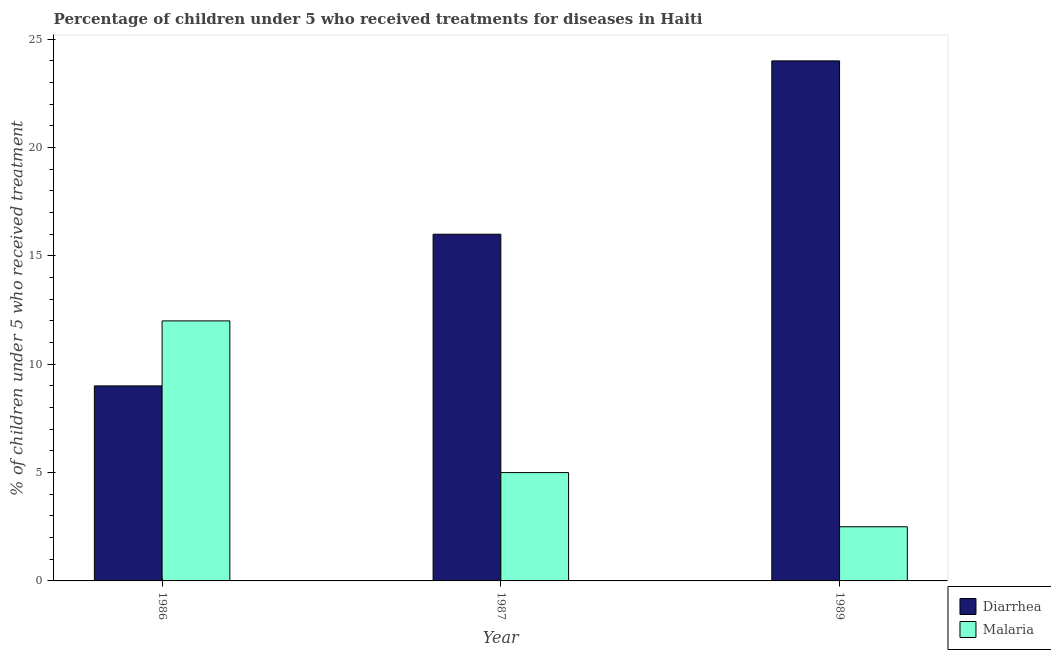Are the number of bars per tick equal to the number of legend labels?
Your answer should be very brief. Yes. Are the number of bars on each tick of the X-axis equal?
Keep it short and to the point. Yes. What is the label of the 1st group of bars from the left?
Offer a terse response. 1986. What is the percentage of children who received treatment for diarrhoea in 1986?
Ensure brevity in your answer.  9. Across all years, what is the maximum percentage of children who received treatment for malaria?
Offer a terse response. 12. Across all years, what is the minimum percentage of children who received treatment for malaria?
Give a very brief answer. 2.5. In which year was the percentage of children who received treatment for diarrhoea maximum?
Give a very brief answer. 1989. In which year was the percentage of children who received treatment for malaria minimum?
Provide a succinct answer. 1989. What is the total percentage of children who received treatment for diarrhoea in the graph?
Your response must be concise. 49. What is the difference between the percentage of children who received treatment for malaria in 1986 and that in 1989?
Your response must be concise. 9.5. What is the difference between the percentage of children who received treatment for diarrhoea in 1986 and the percentage of children who received treatment for malaria in 1989?
Keep it short and to the point. -15. What is the average percentage of children who received treatment for diarrhoea per year?
Provide a succinct answer. 16.33. What is the ratio of the percentage of children who received treatment for malaria in 1986 to that in 1987?
Offer a terse response. 2.4. Is the percentage of children who received treatment for diarrhoea in 1987 less than that in 1989?
Your response must be concise. Yes. What is the difference between the highest and the second highest percentage of children who received treatment for diarrhoea?
Your response must be concise. 8. In how many years, is the percentage of children who received treatment for diarrhoea greater than the average percentage of children who received treatment for diarrhoea taken over all years?
Give a very brief answer. 1. Is the sum of the percentage of children who received treatment for malaria in 1986 and 1989 greater than the maximum percentage of children who received treatment for diarrhoea across all years?
Provide a short and direct response. Yes. What does the 1st bar from the left in 1987 represents?
Your response must be concise. Diarrhea. What does the 2nd bar from the right in 1989 represents?
Make the answer very short. Diarrhea. Are all the bars in the graph horizontal?
Your answer should be compact. No. How many years are there in the graph?
Provide a short and direct response. 3. What is the difference between two consecutive major ticks on the Y-axis?
Provide a succinct answer. 5. Are the values on the major ticks of Y-axis written in scientific E-notation?
Offer a very short reply. No. Does the graph contain any zero values?
Give a very brief answer. No. Does the graph contain grids?
Give a very brief answer. No. How many legend labels are there?
Keep it short and to the point. 2. What is the title of the graph?
Ensure brevity in your answer.  Percentage of children under 5 who received treatments for diseases in Haiti. Does "Official creditors" appear as one of the legend labels in the graph?
Offer a very short reply. No. What is the label or title of the X-axis?
Provide a succinct answer. Year. What is the label or title of the Y-axis?
Provide a succinct answer. % of children under 5 who received treatment. What is the % of children under 5 who received treatment of Diarrhea in 1986?
Offer a terse response. 9. What is the % of children under 5 who received treatment of Diarrhea in 1987?
Ensure brevity in your answer.  16. What is the % of children under 5 who received treatment of Malaria in 1987?
Give a very brief answer. 5. What is the % of children under 5 who received treatment in Diarrhea in 1989?
Offer a very short reply. 24. What is the % of children under 5 who received treatment in Malaria in 1989?
Your response must be concise. 2.5. Across all years, what is the maximum % of children under 5 who received treatment in Diarrhea?
Keep it short and to the point. 24. Across all years, what is the maximum % of children under 5 who received treatment of Malaria?
Offer a very short reply. 12. Across all years, what is the minimum % of children under 5 who received treatment in Malaria?
Your response must be concise. 2.5. What is the total % of children under 5 who received treatment of Malaria in the graph?
Offer a very short reply. 19.5. What is the difference between the % of children under 5 who received treatment in Diarrhea in 1986 and that in 1987?
Offer a terse response. -7. What is the difference between the % of children under 5 who received treatment in Malaria in 1986 and that in 1989?
Offer a terse response. 9.5. What is the difference between the % of children under 5 who received treatment of Malaria in 1987 and that in 1989?
Your response must be concise. 2.5. What is the difference between the % of children under 5 who received treatment in Diarrhea in 1986 and the % of children under 5 who received treatment in Malaria in 1989?
Offer a terse response. 6.5. What is the difference between the % of children under 5 who received treatment in Diarrhea in 1987 and the % of children under 5 who received treatment in Malaria in 1989?
Ensure brevity in your answer.  13.5. What is the average % of children under 5 who received treatment in Diarrhea per year?
Your answer should be compact. 16.33. In the year 1986, what is the difference between the % of children under 5 who received treatment of Diarrhea and % of children under 5 who received treatment of Malaria?
Ensure brevity in your answer.  -3. In the year 1987, what is the difference between the % of children under 5 who received treatment of Diarrhea and % of children under 5 who received treatment of Malaria?
Offer a terse response. 11. In the year 1989, what is the difference between the % of children under 5 who received treatment of Diarrhea and % of children under 5 who received treatment of Malaria?
Make the answer very short. 21.5. What is the ratio of the % of children under 5 who received treatment of Diarrhea in 1986 to that in 1987?
Offer a very short reply. 0.56. What is the difference between the highest and the second highest % of children under 5 who received treatment in Malaria?
Provide a succinct answer. 7. What is the difference between the highest and the lowest % of children under 5 who received treatment of Diarrhea?
Offer a terse response. 15. 